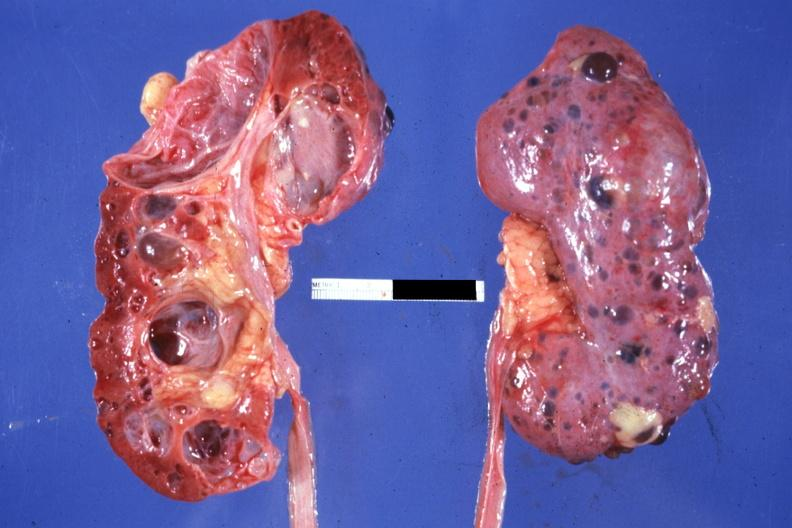s adrenal of premature 30 week gestation gram infant lesion present?
Answer the question using a single word or phrase. No 